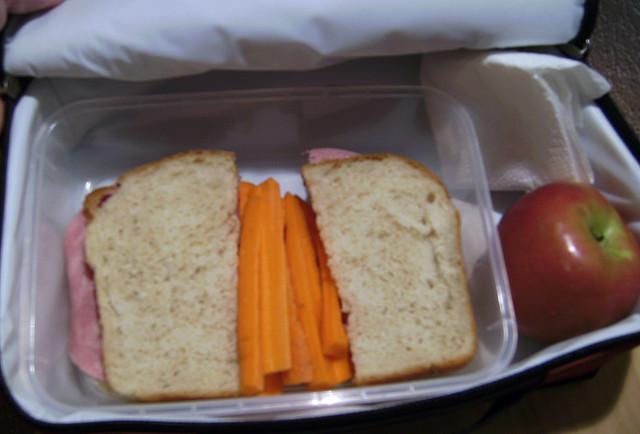How many apples can you see?
Give a very brief answer. 1. How many carrots can you see?
Give a very brief answer. 1. How many sandwiches are in the photo?
Give a very brief answer. 2. 